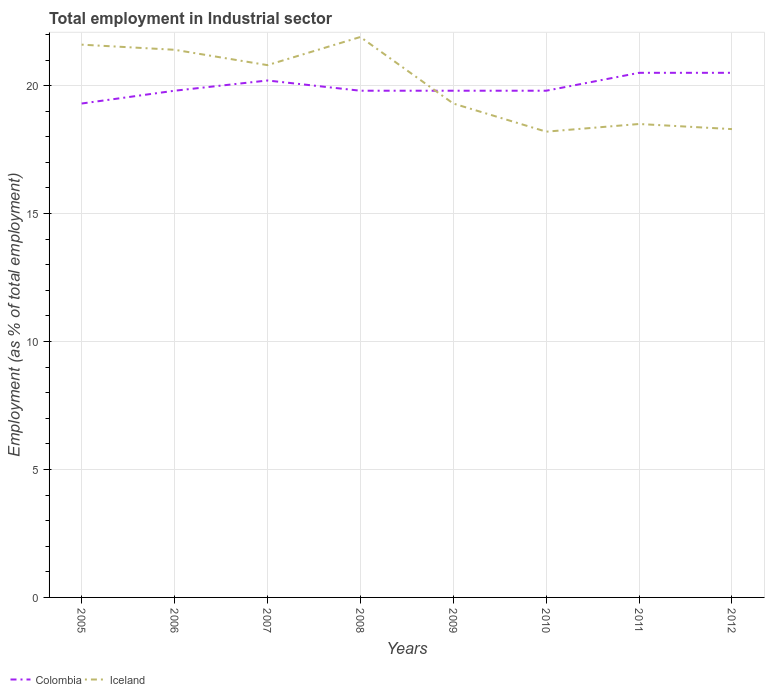How many different coloured lines are there?
Offer a terse response. 2. Does the line corresponding to Iceland intersect with the line corresponding to Colombia?
Give a very brief answer. Yes. Is the number of lines equal to the number of legend labels?
Ensure brevity in your answer.  Yes. Across all years, what is the maximum employment in industrial sector in Iceland?
Keep it short and to the point. 18.2. What is the total employment in industrial sector in Iceland in the graph?
Keep it short and to the point. 3.4. What is the difference between the highest and the second highest employment in industrial sector in Iceland?
Your answer should be very brief. 3.7. What is the difference between the highest and the lowest employment in industrial sector in Iceland?
Provide a succinct answer. 4. Is the employment in industrial sector in Iceland strictly greater than the employment in industrial sector in Colombia over the years?
Ensure brevity in your answer.  No. How many years are there in the graph?
Offer a terse response. 8. Does the graph contain any zero values?
Your answer should be very brief. No. Does the graph contain grids?
Your answer should be compact. Yes. What is the title of the graph?
Keep it short and to the point. Total employment in Industrial sector. Does "Portugal" appear as one of the legend labels in the graph?
Your response must be concise. No. What is the label or title of the Y-axis?
Offer a very short reply. Employment (as % of total employment). What is the Employment (as % of total employment) of Colombia in 2005?
Give a very brief answer. 19.3. What is the Employment (as % of total employment) in Iceland in 2005?
Your response must be concise. 21.6. What is the Employment (as % of total employment) of Colombia in 2006?
Provide a succinct answer. 19.8. What is the Employment (as % of total employment) of Iceland in 2006?
Keep it short and to the point. 21.4. What is the Employment (as % of total employment) in Colombia in 2007?
Your answer should be very brief. 20.2. What is the Employment (as % of total employment) of Iceland in 2007?
Offer a terse response. 20.8. What is the Employment (as % of total employment) in Colombia in 2008?
Your answer should be very brief. 19.8. What is the Employment (as % of total employment) of Iceland in 2008?
Give a very brief answer. 21.9. What is the Employment (as % of total employment) of Colombia in 2009?
Provide a short and direct response. 19.8. What is the Employment (as % of total employment) in Iceland in 2009?
Give a very brief answer. 19.3. What is the Employment (as % of total employment) in Colombia in 2010?
Provide a short and direct response. 19.8. What is the Employment (as % of total employment) in Iceland in 2010?
Your answer should be very brief. 18.2. What is the Employment (as % of total employment) in Iceland in 2012?
Offer a terse response. 18.3. Across all years, what is the maximum Employment (as % of total employment) of Colombia?
Your response must be concise. 20.5. Across all years, what is the maximum Employment (as % of total employment) of Iceland?
Provide a succinct answer. 21.9. Across all years, what is the minimum Employment (as % of total employment) of Colombia?
Your response must be concise. 19.3. Across all years, what is the minimum Employment (as % of total employment) of Iceland?
Make the answer very short. 18.2. What is the total Employment (as % of total employment) of Colombia in the graph?
Give a very brief answer. 159.7. What is the total Employment (as % of total employment) in Iceland in the graph?
Provide a short and direct response. 160. What is the difference between the Employment (as % of total employment) of Colombia in 2005 and that in 2006?
Your response must be concise. -0.5. What is the difference between the Employment (as % of total employment) of Iceland in 2005 and that in 2006?
Your response must be concise. 0.2. What is the difference between the Employment (as % of total employment) in Colombia in 2005 and that in 2007?
Your response must be concise. -0.9. What is the difference between the Employment (as % of total employment) of Iceland in 2005 and that in 2007?
Your answer should be compact. 0.8. What is the difference between the Employment (as % of total employment) in Colombia in 2005 and that in 2008?
Your answer should be compact. -0.5. What is the difference between the Employment (as % of total employment) in Colombia in 2005 and that in 2009?
Ensure brevity in your answer.  -0.5. What is the difference between the Employment (as % of total employment) of Iceland in 2005 and that in 2009?
Offer a terse response. 2.3. What is the difference between the Employment (as % of total employment) of Iceland in 2005 and that in 2010?
Keep it short and to the point. 3.4. What is the difference between the Employment (as % of total employment) of Colombia in 2005 and that in 2012?
Ensure brevity in your answer.  -1.2. What is the difference between the Employment (as % of total employment) in Colombia in 2006 and that in 2007?
Offer a terse response. -0.4. What is the difference between the Employment (as % of total employment) in Iceland in 2006 and that in 2009?
Your answer should be compact. 2.1. What is the difference between the Employment (as % of total employment) in Colombia in 2006 and that in 2010?
Provide a succinct answer. 0. What is the difference between the Employment (as % of total employment) in Iceland in 2006 and that in 2010?
Provide a short and direct response. 3.2. What is the difference between the Employment (as % of total employment) of Colombia in 2006 and that in 2012?
Your response must be concise. -0.7. What is the difference between the Employment (as % of total employment) in Iceland in 2006 and that in 2012?
Make the answer very short. 3.1. What is the difference between the Employment (as % of total employment) of Colombia in 2007 and that in 2008?
Offer a very short reply. 0.4. What is the difference between the Employment (as % of total employment) in Iceland in 2007 and that in 2009?
Your answer should be compact. 1.5. What is the difference between the Employment (as % of total employment) of Colombia in 2007 and that in 2010?
Ensure brevity in your answer.  0.4. What is the difference between the Employment (as % of total employment) of Iceland in 2007 and that in 2010?
Your answer should be very brief. 2.6. What is the difference between the Employment (as % of total employment) in Colombia in 2007 and that in 2011?
Your answer should be very brief. -0.3. What is the difference between the Employment (as % of total employment) of Iceland in 2007 and that in 2011?
Ensure brevity in your answer.  2.3. What is the difference between the Employment (as % of total employment) of Colombia in 2008 and that in 2009?
Give a very brief answer. 0. What is the difference between the Employment (as % of total employment) of Colombia in 2008 and that in 2010?
Keep it short and to the point. 0. What is the difference between the Employment (as % of total employment) of Iceland in 2008 and that in 2010?
Offer a terse response. 3.7. What is the difference between the Employment (as % of total employment) of Colombia in 2008 and that in 2011?
Ensure brevity in your answer.  -0.7. What is the difference between the Employment (as % of total employment) of Iceland in 2008 and that in 2011?
Ensure brevity in your answer.  3.4. What is the difference between the Employment (as % of total employment) of Iceland in 2008 and that in 2012?
Make the answer very short. 3.6. What is the difference between the Employment (as % of total employment) of Colombia in 2009 and that in 2012?
Your answer should be very brief. -0.7. What is the difference between the Employment (as % of total employment) of Colombia in 2010 and that in 2011?
Keep it short and to the point. -0.7. What is the difference between the Employment (as % of total employment) in Iceland in 2010 and that in 2011?
Your response must be concise. -0.3. What is the difference between the Employment (as % of total employment) in Colombia in 2010 and that in 2012?
Make the answer very short. -0.7. What is the difference between the Employment (as % of total employment) in Iceland in 2011 and that in 2012?
Your response must be concise. 0.2. What is the difference between the Employment (as % of total employment) of Colombia in 2005 and the Employment (as % of total employment) of Iceland in 2008?
Your answer should be compact. -2.6. What is the difference between the Employment (as % of total employment) in Colombia in 2005 and the Employment (as % of total employment) in Iceland in 2009?
Your answer should be compact. 0. What is the difference between the Employment (as % of total employment) of Colombia in 2005 and the Employment (as % of total employment) of Iceland in 2010?
Ensure brevity in your answer.  1.1. What is the difference between the Employment (as % of total employment) in Colombia in 2005 and the Employment (as % of total employment) in Iceland in 2012?
Provide a succinct answer. 1. What is the difference between the Employment (as % of total employment) in Colombia in 2006 and the Employment (as % of total employment) in Iceland in 2008?
Offer a very short reply. -2.1. What is the difference between the Employment (as % of total employment) of Colombia in 2006 and the Employment (as % of total employment) of Iceland in 2009?
Provide a short and direct response. 0.5. What is the difference between the Employment (as % of total employment) of Colombia in 2006 and the Employment (as % of total employment) of Iceland in 2010?
Keep it short and to the point. 1.6. What is the difference between the Employment (as % of total employment) in Colombia in 2007 and the Employment (as % of total employment) in Iceland in 2008?
Keep it short and to the point. -1.7. What is the difference between the Employment (as % of total employment) in Colombia in 2007 and the Employment (as % of total employment) in Iceland in 2009?
Your answer should be very brief. 0.9. What is the difference between the Employment (as % of total employment) of Colombia in 2007 and the Employment (as % of total employment) of Iceland in 2010?
Provide a succinct answer. 2. What is the difference between the Employment (as % of total employment) in Colombia in 2008 and the Employment (as % of total employment) in Iceland in 2009?
Give a very brief answer. 0.5. What is the difference between the Employment (as % of total employment) in Colombia in 2008 and the Employment (as % of total employment) in Iceland in 2010?
Make the answer very short. 1.6. What is the difference between the Employment (as % of total employment) in Colombia in 2008 and the Employment (as % of total employment) in Iceland in 2011?
Offer a very short reply. 1.3. What is the difference between the Employment (as % of total employment) in Colombia in 2008 and the Employment (as % of total employment) in Iceland in 2012?
Provide a succinct answer. 1.5. What is the difference between the Employment (as % of total employment) of Colombia in 2010 and the Employment (as % of total employment) of Iceland in 2012?
Give a very brief answer. 1.5. What is the difference between the Employment (as % of total employment) in Colombia in 2011 and the Employment (as % of total employment) in Iceland in 2012?
Provide a succinct answer. 2.2. What is the average Employment (as % of total employment) in Colombia per year?
Ensure brevity in your answer.  19.96. What is the average Employment (as % of total employment) of Iceland per year?
Provide a short and direct response. 20. In the year 2005, what is the difference between the Employment (as % of total employment) of Colombia and Employment (as % of total employment) of Iceland?
Offer a terse response. -2.3. In the year 2008, what is the difference between the Employment (as % of total employment) in Colombia and Employment (as % of total employment) in Iceland?
Your response must be concise. -2.1. What is the ratio of the Employment (as % of total employment) of Colombia in 2005 to that in 2006?
Keep it short and to the point. 0.97. What is the ratio of the Employment (as % of total employment) in Iceland in 2005 to that in 2006?
Ensure brevity in your answer.  1.01. What is the ratio of the Employment (as % of total employment) in Colombia in 2005 to that in 2007?
Keep it short and to the point. 0.96. What is the ratio of the Employment (as % of total employment) in Colombia in 2005 to that in 2008?
Offer a very short reply. 0.97. What is the ratio of the Employment (as % of total employment) in Iceland in 2005 to that in 2008?
Provide a short and direct response. 0.99. What is the ratio of the Employment (as % of total employment) in Colombia in 2005 to that in 2009?
Provide a short and direct response. 0.97. What is the ratio of the Employment (as % of total employment) of Iceland in 2005 to that in 2009?
Give a very brief answer. 1.12. What is the ratio of the Employment (as % of total employment) in Colombia in 2005 to that in 2010?
Your answer should be compact. 0.97. What is the ratio of the Employment (as % of total employment) in Iceland in 2005 to that in 2010?
Give a very brief answer. 1.19. What is the ratio of the Employment (as % of total employment) in Colombia in 2005 to that in 2011?
Keep it short and to the point. 0.94. What is the ratio of the Employment (as % of total employment) in Iceland in 2005 to that in 2011?
Ensure brevity in your answer.  1.17. What is the ratio of the Employment (as % of total employment) in Colombia in 2005 to that in 2012?
Provide a short and direct response. 0.94. What is the ratio of the Employment (as % of total employment) of Iceland in 2005 to that in 2012?
Offer a very short reply. 1.18. What is the ratio of the Employment (as % of total employment) of Colombia in 2006 to that in 2007?
Ensure brevity in your answer.  0.98. What is the ratio of the Employment (as % of total employment) in Iceland in 2006 to that in 2007?
Offer a terse response. 1.03. What is the ratio of the Employment (as % of total employment) of Colombia in 2006 to that in 2008?
Make the answer very short. 1. What is the ratio of the Employment (as % of total employment) of Iceland in 2006 to that in 2008?
Provide a succinct answer. 0.98. What is the ratio of the Employment (as % of total employment) in Iceland in 2006 to that in 2009?
Your answer should be very brief. 1.11. What is the ratio of the Employment (as % of total employment) of Iceland in 2006 to that in 2010?
Provide a succinct answer. 1.18. What is the ratio of the Employment (as % of total employment) of Colombia in 2006 to that in 2011?
Your response must be concise. 0.97. What is the ratio of the Employment (as % of total employment) in Iceland in 2006 to that in 2011?
Keep it short and to the point. 1.16. What is the ratio of the Employment (as % of total employment) of Colombia in 2006 to that in 2012?
Provide a short and direct response. 0.97. What is the ratio of the Employment (as % of total employment) of Iceland in 2006 to that in 2012?
Give a very brief answer. 1.17. What is the ratio of the Employment (as % of total employment) of Colombia in 2007 to that in 2008?
Offer a very short reply. 1.02. What is the ratio of the Employment (as % of total employment) in Iceland in 2007 to that in 2008?
Ensure brevity in your answer.  0.95. What is the ratio of the Employment (as % of total employment) of Colombia in 2007 to that in 2009?
Offer a very short reply. 1.02. What is the ratio of the Employment (as % of total employment) of Iceland in 2007 to that in 2009?
Offer a very short reply. 1.08. What is the ratio of the Employment (as % of total employment) in Colombia in 2007 to that in 2010?
Offer a very short reply. 1.02. What is the ratio of the Employment (as % of total employment) in Iceland in 2007 to that in 2010?
Make the answer very short. 1.14. What is the ratio of the Employment (as % of total employment) in Colombia in 2007 to that in 2011?
Your answer should be very brief. 0.99. What is the ratio of the Employment (as % of total employment) of Iceland in 2007 to that in 2011?
Your answer should be compact. 1.12. What is the ratio of the Employment (as % of total employment) of Colombia in 2007 to that in 2012?
Ensure brevity in your answer.  0.99. What is the ratio of the Employment (as % of total employment) of Iceland in 2007 to that in 2012?
Your answer should be very brief. 1.14. What is the ratio of the Employment (as % of total employment) of Colombia in 2008 to that in 2009?
Your answer should be very brief. 1. What is the ratio of the Employment (as % of total employment) of Iceland in 2008 to that in 2009?
Ensure brevity in your answer.  1.13. What is the ratio of the Employment (as % of total employment) in Colombia in 2008 to that in 2010?
Make the answer very short. 1. What is the ratio of the Employment (as % of total employment) of Iceland in 2008 to that in 2010?
Give a very brief answer. 1.2. What is the ratio of the Employment (as % of total employment) of Colombia in 2008 to that in 2011?
Offer a very short reply. 0.97. What is the ratio of the Employment (as % of total employment) in Iceland in 2008 to that in 2011?
Ensure brevity in your answer.  1.18. What is the ratio of the Employment (as % of total employment) in Colombia in 2008 to that in 2012?
Your answer should be very brief. 0.97. What is the ratio of the Employment (as % of total employment) of Iceland in 2008 to that in 2012?
Provide a short and direct response. 1.2. What is the ratio of the Employment (as % of total employment) of Colombia in 2009 to that in 2010?
Your answer should be compact. 1. What is the ratio of the Employment (as % of total employment) in Iceland in 2009 to that in 2010?
Provide a succinct answer. 1.06. What is the ratio of the Employment (as % of total employment) of Colombia in 2009 to that in 2011?
Give a very brief answer. 0.97. What is the ratio of the Employment (as % of total employment) in Iceland in 2009 to that in 2011?
Give a very brief answer. 1.04. What is the ratio of the Employment (as % of total employment) of Colombia in 2009 to that in 2012?
Keep it short and to the point. 0.97. What is the ratio of the Employment (as % of total employment) of Iceland in 2009 to that in 2012?
Your response must be concise. 1.05. What is the ratio of the Employment (as % of total employment) in Colombia in 2010 to that in 2011?
Provide a short and direct response. 0.97. What is the ratio of the Employment (as % of total employment) in Iceland in 2010 to that in 2011?
Offer a terse response. 0.98. What is the ratio of the Employment (as % of total employment) of Colombia in 2010 to that in 2012?
Provide a short and direct response. 0.97. What is the ratio of the Employment (as % of total employment) of Iceland in 2010 to that in 2012?
Provide a succinct answer. 0.99. What is the ratio of the Employment (as % of total employment) in Iceland in 2011 to that in 2012?
Ensure brevity in your answer.  1.01. 